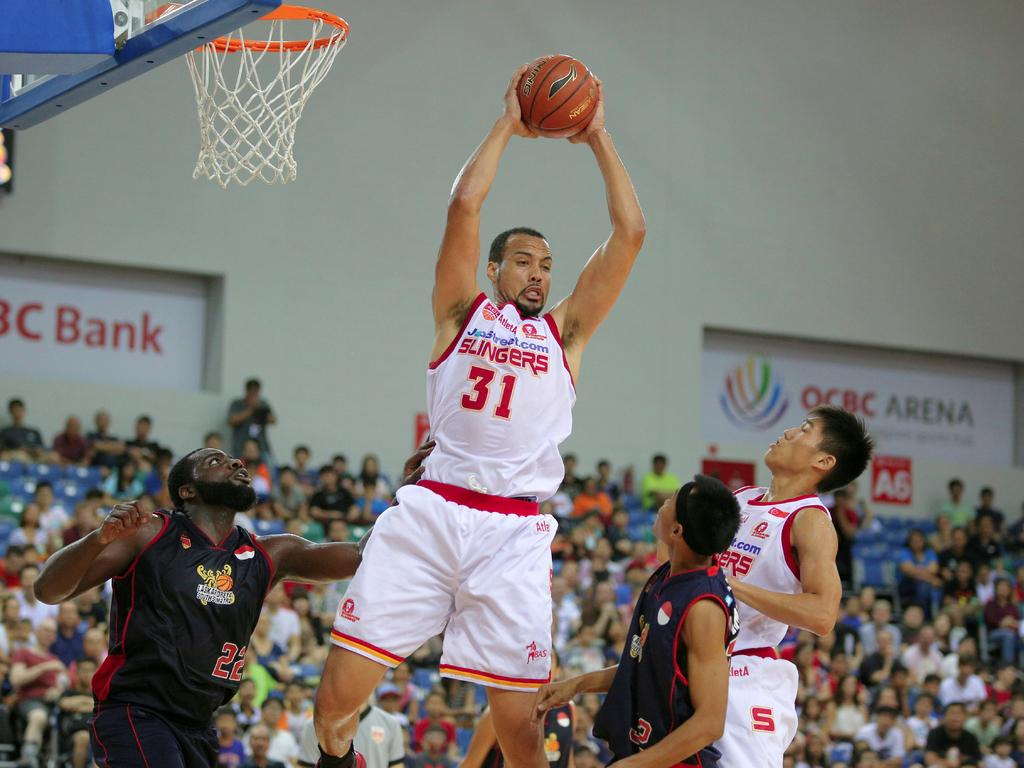<image>
Relay a brief, clear account of the picture shown. number 31 of the white team is holding the ball 